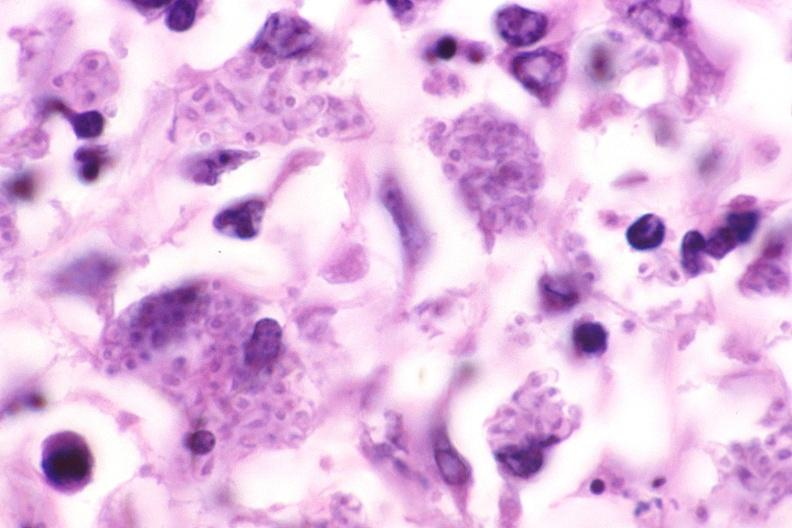s opened larynx present?
Answer the question using a single word or phrase. No 